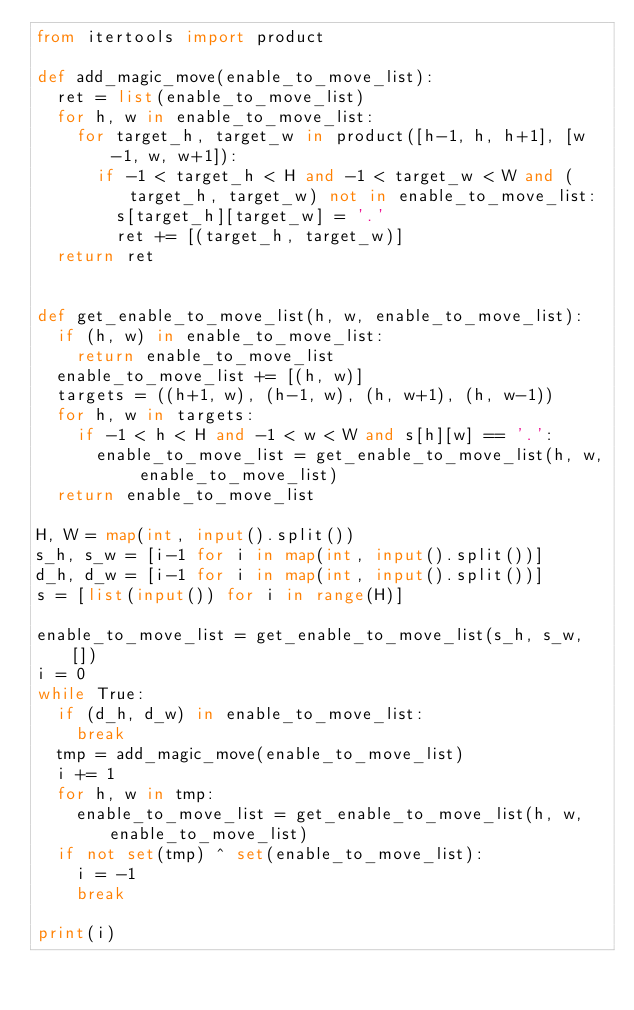Convert code to text. <code><loc_0><loc_0><loc_500><loc_500><_Python_>from itertools import product

def add_magic_move(enable_to_move_list):
  ret = list(enable_to_move_list)
  for h, w in enable_to_move_list:
    for target_h, target_w in product([h-1, h, h+1], [w-1, w, w+1]):
      if -1 < target_h < H and -1 < target_w < W and (target_h, target_w) not in enable_to_move_list:
        s[target_h][target_w] = '.'
        ret += [(target_h, target_w)]
  return ret
    

def get_enable_to_move_list(h, w, enable_to_move_list):
  if (h, w) in enable_to_move_list:
    return enable_to_move_list
  enable_to_move_list += [(h, w)]
  targets = ((h+1, w), (h-1, w), (h, w+1), (h, w-1))
  for h, w in targets:
    if -1 < h < H and -1 < w < W and s[h][w] == '.':
      enable_to_move_list = get_enable_to_move_list(h, w, enable_to_move_list)
  return enable_to_move_list

H, W = map(int, input().split())
s_h, s_w = [i-1 for i in map(int, input().split())]
d_h, d_w = [i-1 for i in map(int, input().split())]
s = [list(input()) for i in range(H)]

enable_to_move_list = get_enable_to_move_list(s_h, s_w, [])
i = 0
while True:
  if (d_h, d_w) in enable_to_move_list:
    break
  tmp = add_magic_move(enable_to_move_list)
  i += 1
  for h, w in tmp:
  	enable_to_move_list = get_enable_to_move_list(h, w, enable_to_move_list)
  if not set(tmp) ^ set(enable_to_move_list):
    i = -1
    break

print(i)</code> 